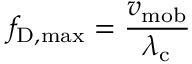<formula> <loc_0><loc_0><loc_500><loc_500>f _ { D , \max } = { \frac { v _ { m o b } } { \lambda _ { c } } }</formula> 